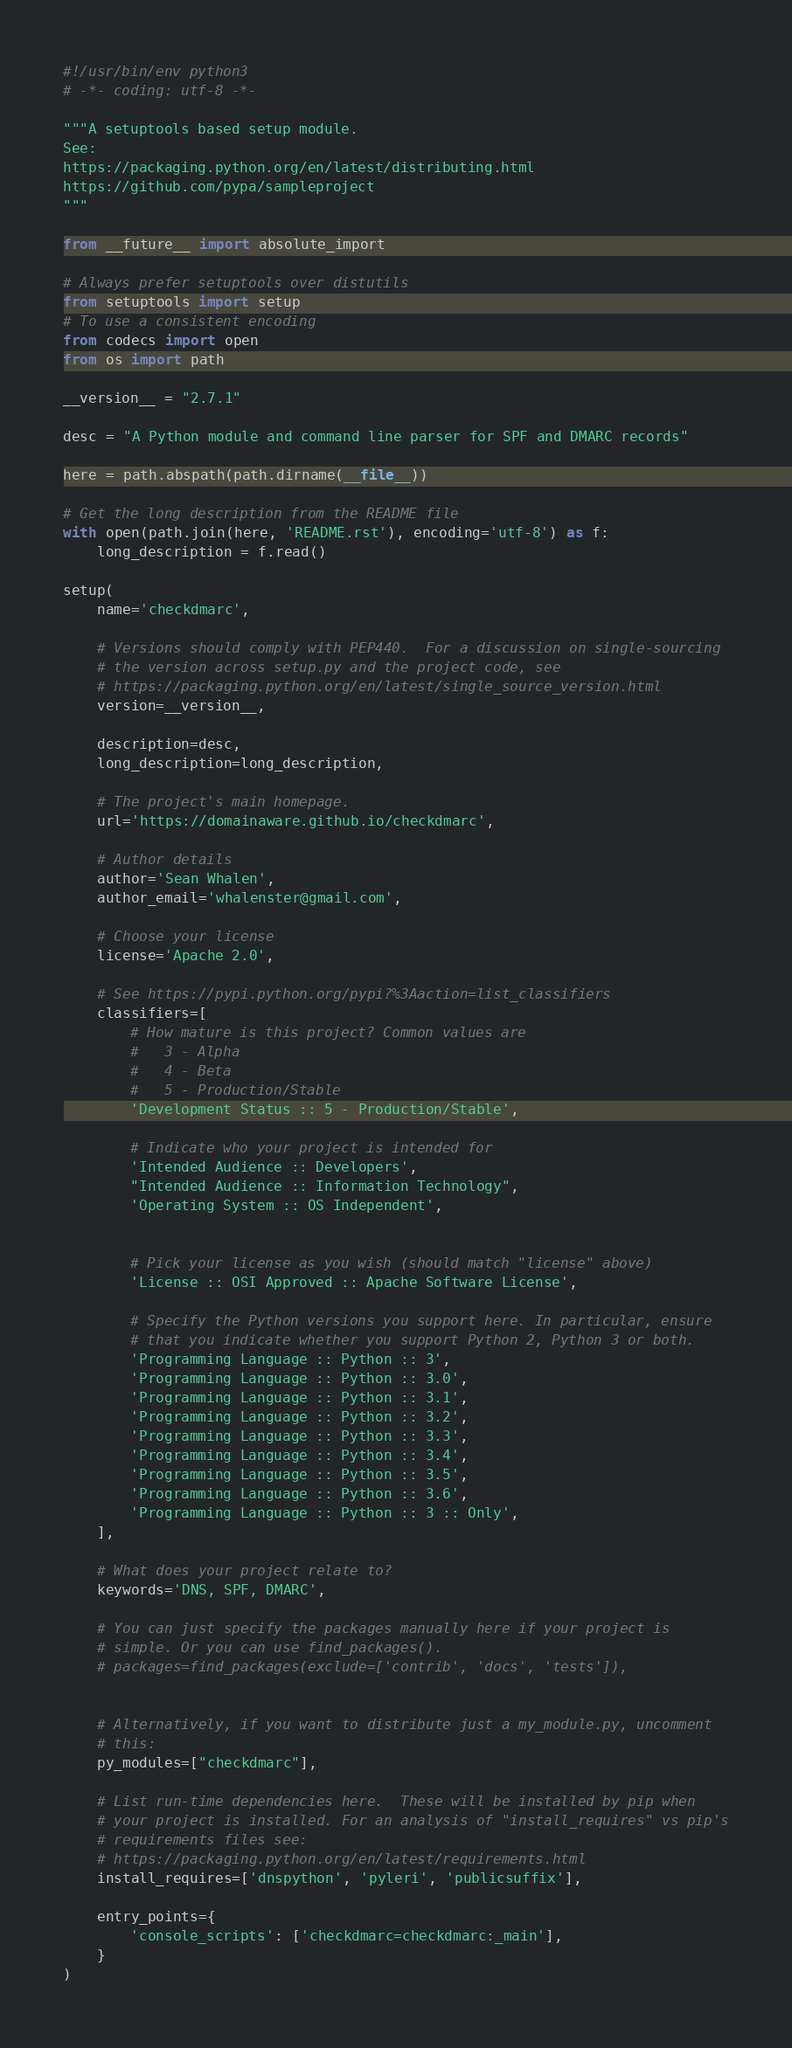Convert code to text. <code><loc_0><loc_0><loc_500><loc_500><_Python_>#!/usr/bin/env python3
# -*- coding: utf-8 -*-

"""A setuptools based setup module.
See:
https://packaging.python.org/en/latest/distributing.html
https://github.com/pypa/sampleproject
"""

from __future__ import absolute_import

# Always prefer setuptools over distutils
from setuptools import setup
# To use a consistent encoding
from codecs import open
from os import path

__version__ = "2.7.1"

desc = "A Python module and command line parser for SPF and DMARC records"

here = path.abspath(path.dirname(__file__))

# Get the long description from the README file
with open(path.join(here, 'README.rst'), encoding='utf-8') as f:
    long_description = f.read()

setup(
    name='checkdmarc',

    # Versions should comply with PEP440.  For a discussion on single-sourcing
    # the version across setup.py and the project code, see
    # https://packaging.python.org/en/latest/single_source_version.html
    version=__version__,

    description=desc,
    long_description=long_description,

    # The project's main homepage.
    url='https://domainaware.github.io/checkdmarc',

    # Author details
    author='Sean Whalen',
    author_email='whalenster@gmail.com',

    # Choose your license
    license='Apache 2.0',

    # See https://pypi.python.org/pypi?%3Aaction=list_classifiers
    classifiers=[
        # How mature is this project? Common values are
        #   3 - Alpha
        #   4 - Beta
        #   5 - Production/Stable
        'Development Status :: 5 - Production/Stable',

        # Indicate who your project is intended for
        'Intended Audience :: Developers',
        "Intended Audience :: Information Technology",
        'Operating System :: OS Independent',


        # Pick your license as you wish (should match "license" above)
        'License :: OSI Approved :: Apache Software License',

        # Specify the Python versions you support here. In particular, ensure
        # that you indicate whether you support Python 2, Python 3 or both.
        'Programming Language :: Python :: 3',
        'Programming Language :: Python :: 3.0',
        'Programming Language :: Python :: 3.1',
        'Programming Language :: Python :: 3.2',
        'Programming Language :: Python :: 3.3',
        'Programming Language :: Python :: 3.4',
        'Programming Language :: Python :: 3.5',
        'Programming Language :: Python :: 3.6',
        'Programming Language :: Python :: 3 :: Only',
    ],

    # What does your project relate to?
    keywords='DNS, SPF, DMARC',

    # You can just specify the packages manually here if your project is
    # simple. Or you can use find_packages().
    # packages=find_packages(exclude=['contrib', 'docs', 'tests']),


    # Alternatively, if you want to distribute just a my_module.py, uncomment
    # this:
    py_modules=["checkdmarc"],

    # List run-time dependencies here.  These will be installed by pip when
    # your project is installed. For an analysis of "install_requires" vs pip's
    # requirements files see:
    # https://packaging.python.org/en/latest/requirements.html
    install_requires=['dnspython', 'pyleri', 'publicsuffix'],

    entry_points={
        'console_scripts': ['checkdmarc=checkdmarc:_main'],
    }
)
</code> 